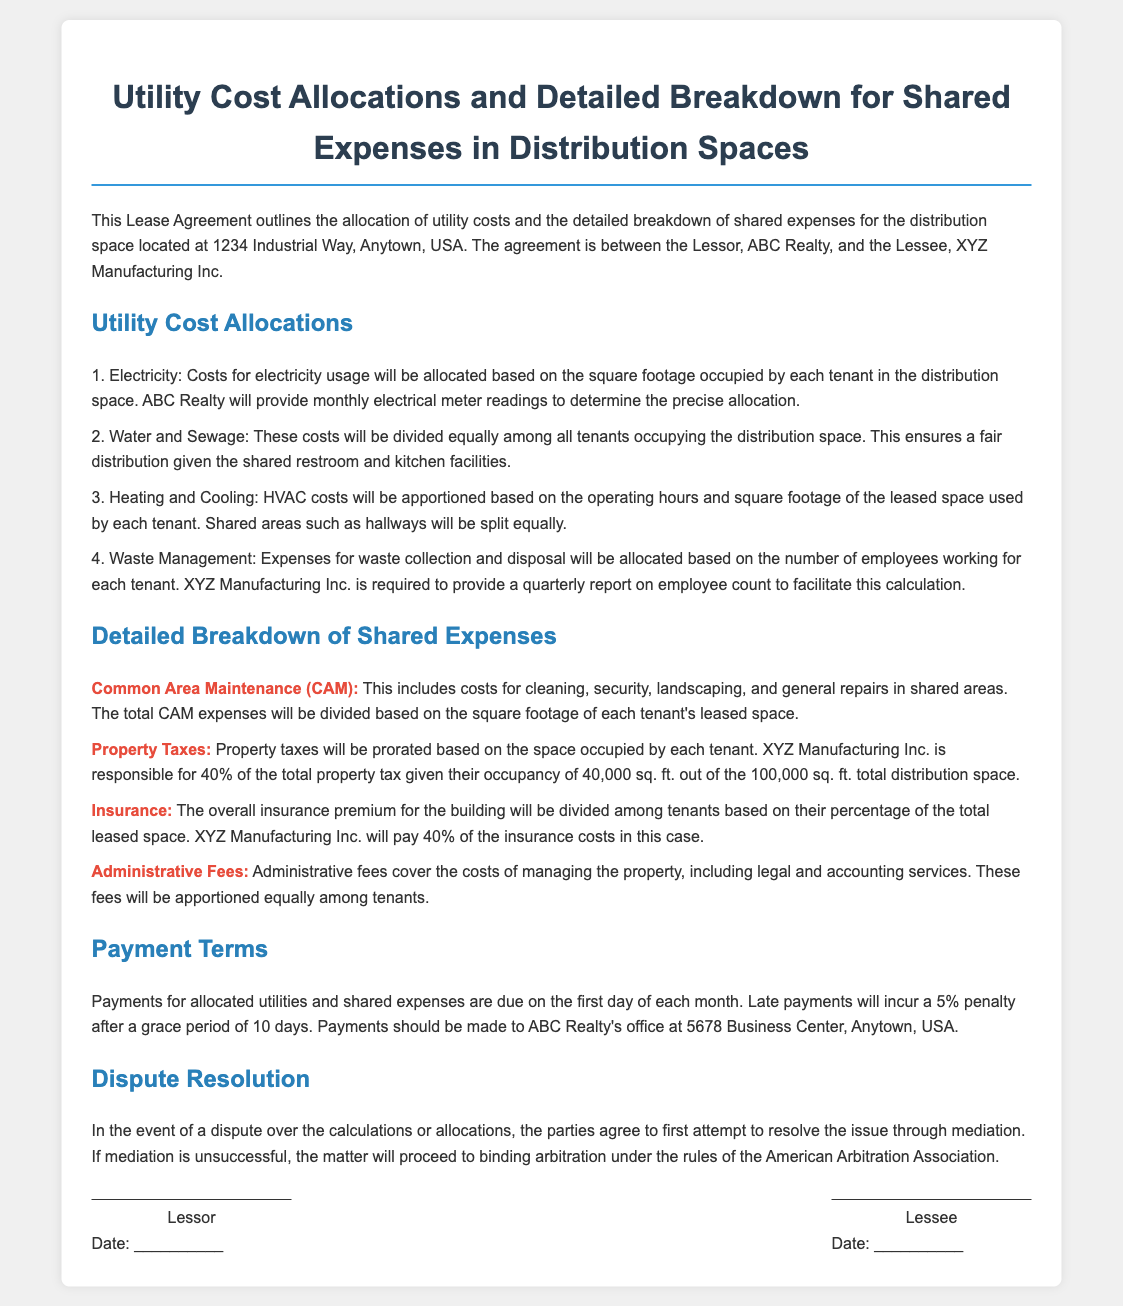What is the address of the distribution space? The address is specifically mentioned at the beginning of the document.
Answer: 1234 Industrial Way, Anytown, USA Who is responsible for providing monthly electrical meter readings? The document states that ABC Realty will provide these readings to determine allocation.
Answer: ABC Realty What percentage of property taxes is XYZ Manufacturing Inc. responsible for? This percentage is indicated in the breakdown of property taxes section.
Answer: 40% How often is XYZ Manufacturing Inc. required to provide a report on employee count? The lease specifies the frequency of the report for accurate expense allocation.
Answer: Quarterly What kind of expenses does Common Area Maintenance (CAM) include? The document lists specific costs covered under CAM expenses.
Answer: Cleaning, security, landscaping, and general repairs What is the penalty for late payments? The document clearly states the consequence of late payments after a grace period.
Answer: 5% How will the Waste Management expenses be allocated? This information requires understanding the criteria for expense allocation described in the lease.
Answer: Based on the number of employees What are the payment due dates specified in the document? The payment terms section outlines when payments should be made.
Answer: First day of each month What action is agreed upon for dispute resolution? The document describes the process that parties will follow in the case of a disagreement.
Answer: Mediation 